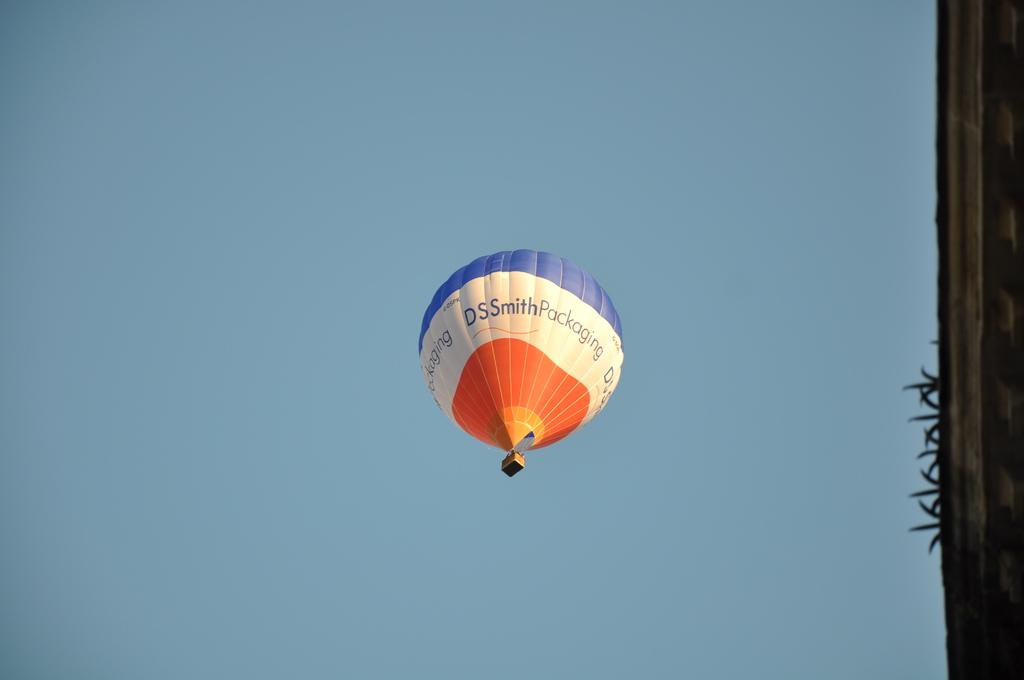What kind of packaging?
Give a very brief answer. Ds smith. What kind of company is ds smith?
Make the answer very short. Packaging. 